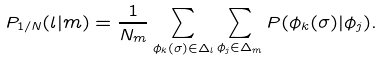<formula> <loc_0><loc_0><loc_500><loc_500>P _ { { 1 } / N } ( l | m ) = \frac { 1 } { N _ { m } } \sum _ { \phi _ { k } ( \sigma ) \in \Delta _ { l } } \sum _ { \phi _ { j } \in \Delta _ { m } } P ( \phi _ { k } ( \sigma ) | \phi _ { j } ) .</formula> 